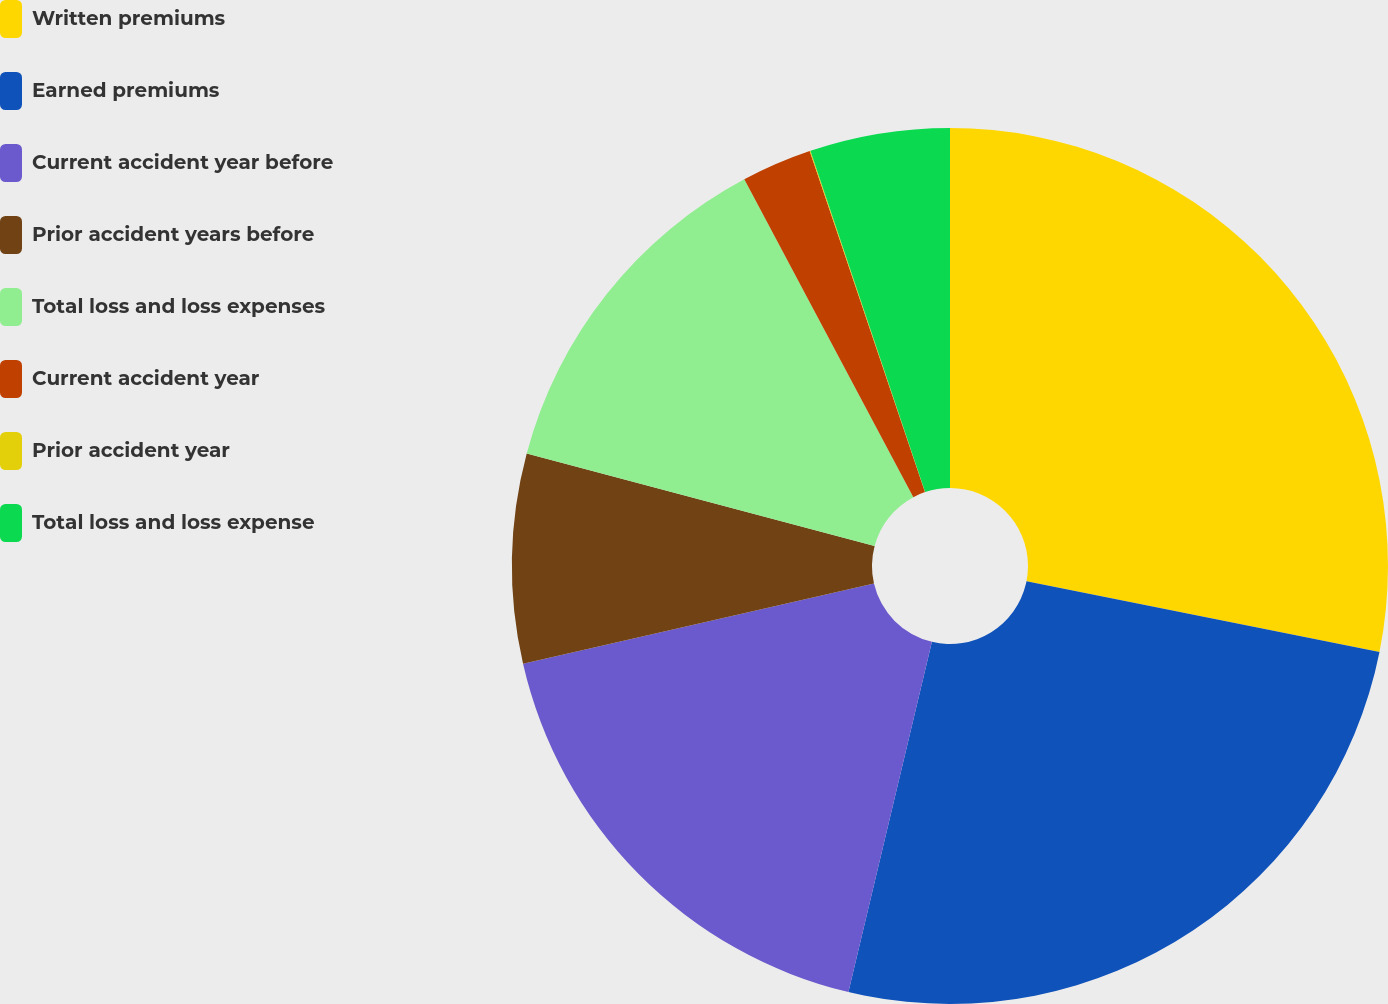Convert chart to OTSL. <chart><loc_0><loc_0><loc_500><loc_500><pie_chart><fcel>Written premiums<fcel>Earned premiums<fcel>Current accident year before<fcel>Prior accident years before<fcel>Total loss and loss expenses<fcel>Current accident year<fcel>Prior accident year<fcel>Total loss and loss expense<nl><fcel>28.14%<fcel>25.58%<fcel>17.69%<fcel>7.72%<fcel>13.08%<fcel>2.59%<fcel>0.03%<fcel>5.16%<nl></chart> 